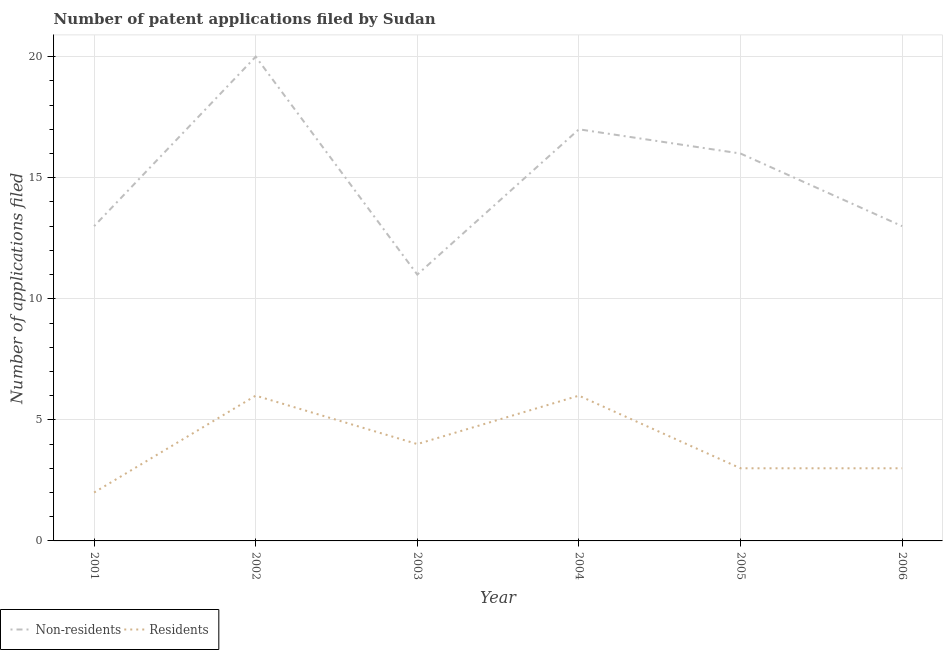How many different coloured lines are there?
Keep it short and to the point. 2. Does the line corresponding to number of patent applications by residents intersect with the line corresponding to number of patent applications by non residents?
Keep it short and to the point. No. Is the number of lines equal to the number of legend labels?
Your response must be concise. Yes. What is the number of patent applications by residents in 2001?
Your answer should be very brief. 2. Across all years, what is the maximum number of patent applications by non residents?
Your answer should be very brief. 20. Across all years, what is the minimum number of patent applications by non residents?
Your answer should be very brief. 11. What is the total number of patent applications by residents in the graph?
Offer a terse response. 24. What is the difference between the number of patent applications by non residents in 2003 and that in 2005?
Provide a succinct answer. -5. What is the difference between the number of patent applications by non residents in 2006 and the number of patent applications by residents in 2005?
Give a very brief answer. 10. What is the average number of patent applications by residents per year?
Provide a succinct answer. 4. In the year 2005, what is the difference between the number of patent applications by residents and number of patent applications by non residents?
Make the answer very short. -13. In how many years, is the number of patent applications by residents greater than 18?
Keep it short and to the point. 0. What is the ratio of the number of patent applications by non residents in 2002 to that in 2006?
Your answer should be very brief. 1.54. Is the number of patent applications by residents in 2005 less than that in 2006?
Give a very brief answer. No. Is the difference between the number of patent applications by non residents in 2002 and 2004 greater than the difference between the number of patent applications by residents in 2002 and 2004?
Ensure brevity in your answer.  Yes. What is the difference between the highest and the lowest number of patent applications by non residents?
Provide a succinct answer. 9. In how many years, is the number of patent applications by residents greater than the average number of patent applications by residents taken over all years?
Offer a terse response. 2. Does the number of patent applications by non residents monotonically increase over the years?
Your answer should be compact. No. Is the number of patent applications by residents strictly less than the number of patent applications by non residents over the years?
Offer a terse response. Yes. How many years are there in the graph?
Give a very brief answer. 6. What is the title of the graph?
Your answer should be very brief. Number of patent applications filed by Sudan. Does "External balance on goods" appear as one of the legend labels in the graph?
Give a very brief answer. No. What is the label or title of the Y-axis?
Your answer should be compact. Number of applications filed. What is the Number of applications filed in Residents in 2005?
Offer a terse response. 3. What is the Number of applications filed in Residents in 2006?
Provide a succinct answer. 3. Across all years, what is the maximum Number of applications filed of Non-residents?
Ensure brevity in your answer.  20. Across all years, what is the minimum Number of applications filed of Non-residents?
Give a very brief answer. 11. What is the total Number of applications filed of Non-residents in the graph?
Your answer should be compact. 90. What is the total Number of applications filed of Residents in the graph?
Keep it short and to the point. 24. What is the difference between the Number of applications filed of Non-residents in 2001 and that in 2002?
Provide a short and direct response. -7. What is the difference between the Number of applications filed in Residents in 2001 and that in 2002?
Offer a very short reply. -4. What is the difference between the Number of applications filed of Residents in 2001 and that in 2003?
Make the answer very short. -2. What is the difference between the Number of applications filed of Non-residents in 2001 and that in 2004?
Your response must be concise. -4. What is the difference between the Number of applications filed of Residents in 2001 and that in 2005?
Provide a succinct answer. -1. What is the difference between the Number of applications filed of Residents in 2001 and that in 2006?
Offer a terse response. -1. What is the difference between the Number of applications filed in Residents in 2002 and that in 2003?
Ensure brevity in your answer.  2. What is the difference between the Number of applications filed of Non-residents in 2002 and that in 2004?
Your answer should be very brief. 3. What is the difference between the Number of applications filed of Non-residents in 2002 and that in 2005?
Provide a short and direct response. 4. What is the difference between the Number of applications filed in Non-residents in 2002 and that in 2006?
Keep it short and to the point. 7. What is the difference between the Number of applications filed of Non-residents in 2003 and that in 2004?
Give a very brief answer. -6. What is the difference between the Number of applications filed in Non-residents in 2003 and that in 2005?
Your response must be concise. -5. What is the difference between the Number of applications filed in Residents in 2003 and that in 2005?
Provide a succinct answer. 1. What is the difference between the Number of applications filed of Non-residents in 2003 and that in 2006?
Give a very brief answer. -2. What is the difference between the Number of applications filed of Residents in 2003 and that in 2006?
Offer a terse response. 1. What is the difference between the Number of applications filed of Non-residents in 2004 and that in 2006?
Provide a short and direct response. 4. What is the difference between the Number of applications filed of Non-residents in 2005 and that in 2006?
Make the answer very short. 3. What is the difference between the Number of applications filed in Non-residents in 2001 and the Number of applications filed in Residents in 2006?
Give a very brief answer. 10. What is the difference between the Number of applications filed of Non-residents in 2002 and the Number of applications filed of Residents in 2003?
Your answer should be compact. 16. What is the difference between the Number of applications filed of Non-residents in 2003 and the Number of applications filed of Residents in 2004?
Offer a very short reply. 5. What is the difference between the Number of applications filed of Non-residents in 2003 and the Number of applications filed of Residents in 2005?
Make the answer very short. 8. What is the difference between the Number of applications filed of Non-residents in 2004 and the Number of applications filed of Residents in 2006?
Ensure brevity in your answer.  14. What is the average Number of applications filed of Residents per year?
Ensure brevity in your answer.  4. In the year 2001, what is the difference between the Number of applications filed of Non-residents and Number of applications filed of Residents?
Offer a terse response. 11. In the year 2002, what is the difference between the Number of applications filed of Non-residents and Number of applications filed of Residents?
Your answer should be compact. 14. In the year 2003, what is the difference between the Number of applications filed in Non-residents and Number of applications filed in Residents?
Make the answer very short. 7. In the year 2004, what is the difference between the Number of applications filed in Non-residents and Number of applications filed in Residents?
Offer a terse response. 11. What is the ratio of the Number of applications filed of Non-residents in 2001 to that in 2002?
Keep it short and to the point. 0.65. What is the ratio of the Number of applications filed of Residents in 2001 to that in 2002?
Make the answer very short. 0.33. What is the ratio of the Number of applications filed of Non-residents in 2001 to that in 2003?
Keep it short and to the point. 1.18. What is the ratio of the Number of applications filed in Non-residents in 2001 to that in 2004?
Your answer should be very brief. 0.76. What is the ratio of the Number of applications filed of Non-residents in 2001 to that in 2005?
Provide a succinct answer. 0.81. What is the ratio of the Number of applications filed in Residents in 2001 to that in 2005?
Provide a succinct answer. 0.67. What is the ratio of the Number of applications filed in Residents in 2001 to that in 2006?
Ensure brevity in your answer.  0.67. What is the ratio of the Number of applications filed in Non-residents in 2002 to that in 2003?
Give a very brief answer. 1.82. What is the ratio of the Number of applications filed of Residents in 2002 to that in 2003?
Provide a succinct answer. 1.5. What is the ratio of the Number of applications filed in Non-residents in 2002 to that in 2004?
Offer a terse response. 1.18. What is the ratio of the Number of applications filed in Residents in 2002 to that in 2004?
Ensure brevity in your answer.  1. What is the ratio of the Number of applications filed of Non-residents in 2002 to that in 2005?
Make the answer very short. 1.25. What is the ratio of the Number of applications filed in Non-residents in 2002 to that in 2006?
Offer a terse response. 1.54. What is the ratio of the Number of applications filed of Residents in 2002 to that in 2006?
Make the answer very short. 2. What is the ratio of the Number of applications filed in Non-residents in 2003 to that in 2004?
Ensure brevity in your answer.  0.65. What is the ratio of the Number of applications filed in Residents in 2003 to that in 2004?
Your answer should be very brief. 0.67. What is the ratio of the Number of applications filed of Non-residents in 2003 to that in 2005?
Provide a short and direct response. 0.69. What is the ratio of the Number of applications filed of Residents in 2003 to that in 2005?
Provide a short and direct response. 1.33. What is the ratio of the Number of applications filed of Non-residents in 2003 to that in 2006?
Your answer should be very brief. 0.85. What is the ratio of the Number of applications filed of Non-residents in 2004 to that in 2005?
Offer a terse response. 1.06. What is the ratio of the Number of applications filed in Non-residents in 2004 to that in 2006?
Offer a terse response. 1.31. What is the ratio of the Number of applications filed of Non-residents in 2005 to that in 2006?
Your answer should be compact. 1.23. What is the difference between the highest and the lowest Number of applications filed in Non-residents?
Provide a succinct answer. 9. 